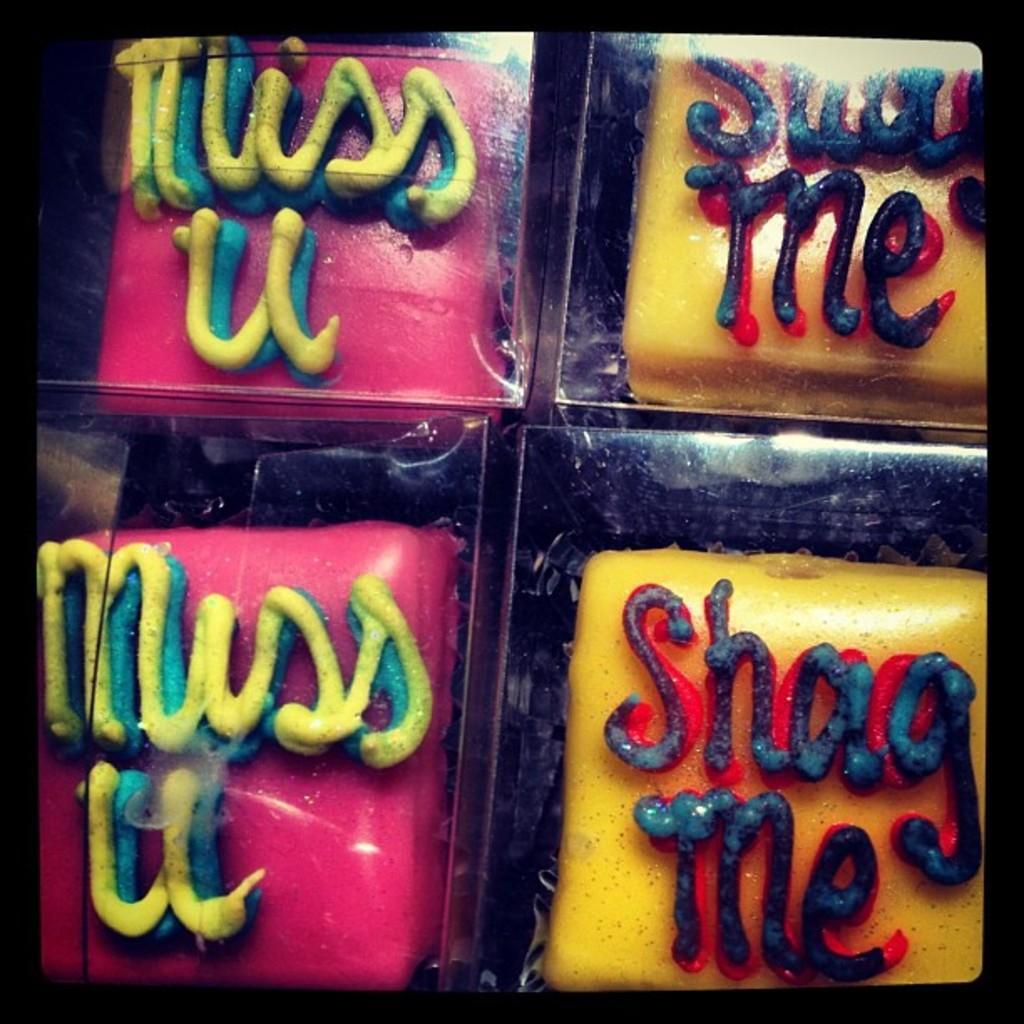Please provide a concise description of this image. In this image I can see pink and yellow color boards and text. This image looks like a photo frame. 